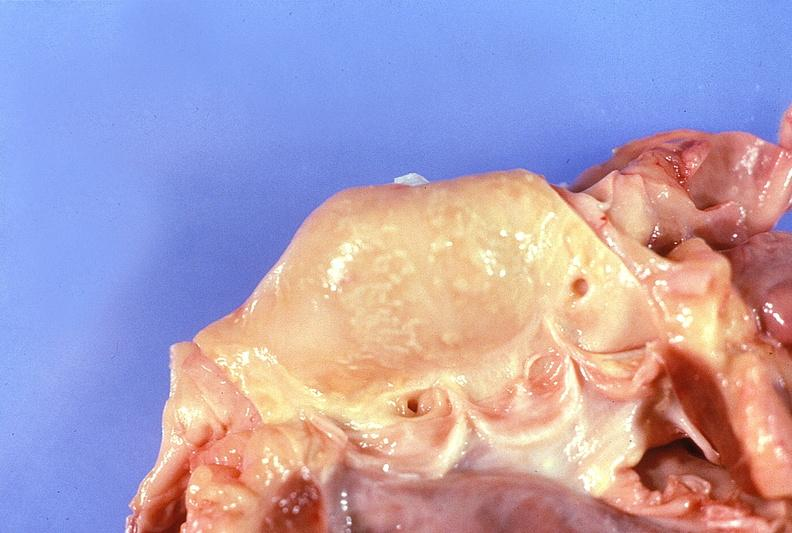s this photo of infant from head to toe present?
Answer the question using a single word or phrase. No 